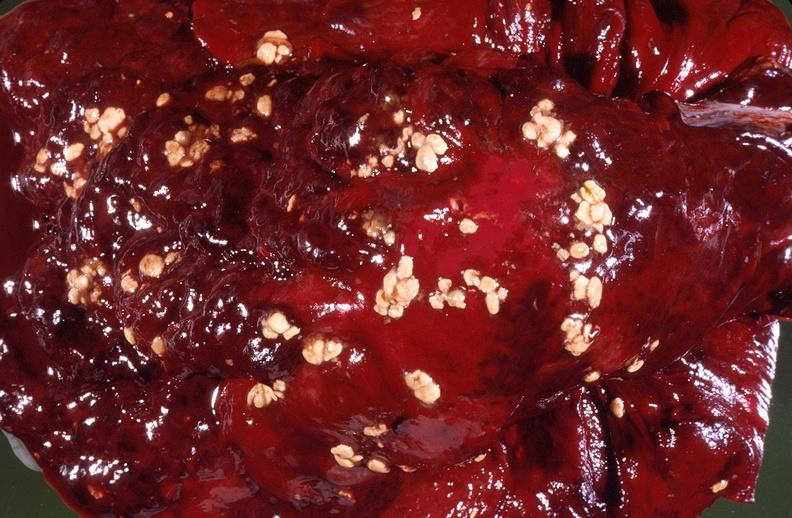what is present?
Answer the question using a single word or phrase. Respiratory 